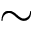<formula> <loc_0><loc_0><loc_500><loc_500>\sim</formula> 